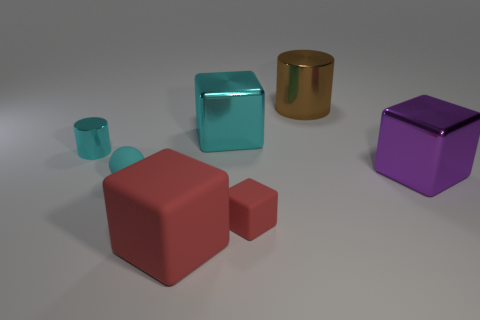What number of big red things are made of the same material as the brown cylinder?
Provide a succinct answer. 0. How many objects are tiny gray rubber spheres or big matte objects?
Give a very brief answer. 1. Are any big red cubes visible?
Give a very brief answer. Yes. What is the big red thing to the right of the metallic cylinder that is left of the large shiny cube that is to the left of the big brown cylinder made of?
Your answer should be compact. Rubber. Is the number of big red rubber blocks that are left of the large red matte block less than the number of large green cylinders?
Make the answer very short. No. There is a red block that is the same size as the cyan matte thing; what is its material?
Make the answer very short. Rubber. There is a thing that is both right of the big cyan shiny object and to the left of the brown cylinder; how big is it?
Your answer should be very brief. Small. There is another red rubber thing that is the same shape as the large red rubber thing; what size is it?
Your answer should be very brief. Small. What number of things are either cyan matte objects or blocks that are behind the tiny matte ball?
Ensure brevity in your answer.  3. The big cyan thing is what shape?
Ensure brevity in your answer.  Cube. 